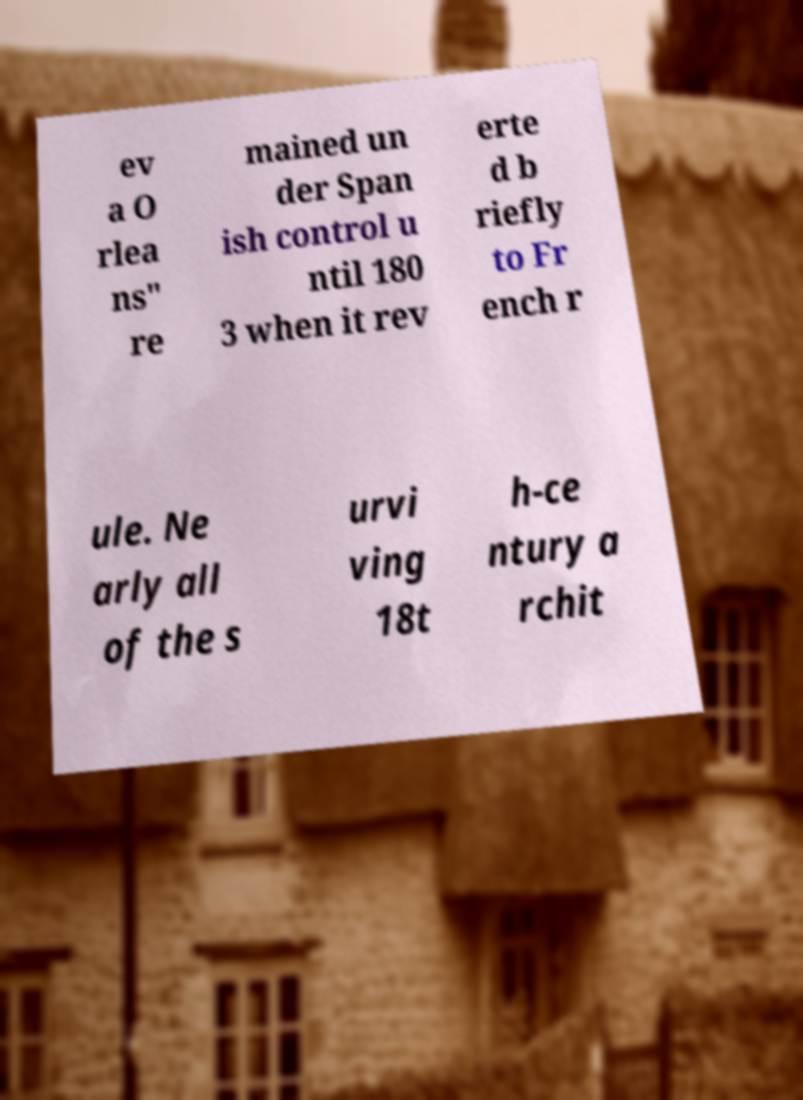Could you assist in decoding the text presented in this image and type it out clearly? ev a O rlea ns" re mained un der Span ish control u ntil 180 3 when it rev erte d b riefly to Fr ench r ule. Ne arly all of the s urvi ving 18t h-ce ntury a rchit 